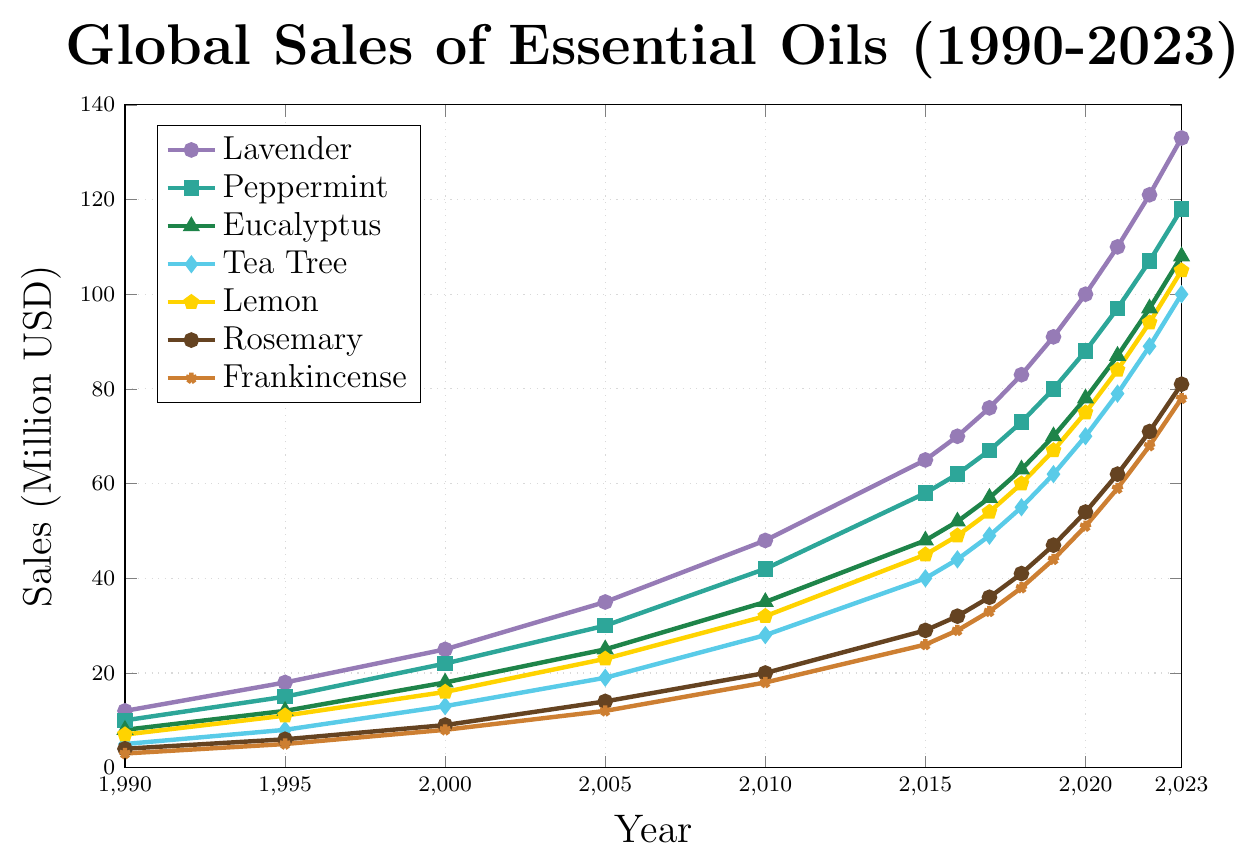What is the overall trend in the sales of Lavender essential oil from 1990 to 2023? Observe the line chart for Lavender's sales, indicated by the lavender-colored line with circular markers. The line shows a consistent upward trend from 1990 (12 million USD) to 2023 (133 million USD).
Answer: Increasing Which essential oil had the highest sales in 2023, and what was the sales figure? Compare the final points (year 2023) for all lines. The Lavender oil line reaches the highest point at 133 million USD.
Answer: Lavender, 133 million USD Between 1995 and 2000, which essential oil showed the greatest increase in sales? Calculate the difference in sales for each essential oil between 1995 and 2000 (Lavender: 7, Peppermint: 7, Eucalyptus: 6, Tea Tree: 5, Lemon: 5, Rosemary: 3, Frankincense: 3). The highest increase is seen in Lavender and Peppermint, with a 7 million USD increase each.
Answer: Lavender and Peppermint By how much did Tea Tree oil sales increase from 2010 to 2020? Find the sales in 2010 (28 million USD) and 2020 (70 million USD) for Tea Tree oil and then calculate the difference (70 - 28 = 42).
Answer: 42 million USD Which essential oil had the least sales growth from 1990 to 2023? Calculate the overall growth from 1990 to 2023 for each oil (Lavender: 121, Peppermint: 108, Eucalyptus: 100, Tea Tree: 95, Lemon: 98, Rosemary: 77, Frankincense: 75). The least growth is seen in Frankincense, with a growth of 75 million USD.
Answer: Frankincense What is the average sales of Eucalyptus essential oil from 1990 to 2023? Sum the sales values for Eucalyptus from 1990 to 2023 (gamma: 8+12+18+25+35+48+52+57+63+70+78+87+97+108 = 760) and divide by the number of years (14). The average sales are 760 / 14 = approximately 54.29 million USD.
Answer: Approximately 54.29 million USD Compare the sales difference between Lemon and Rosemary essential oils in 2023. Identify the sales figures in 2023 (Lemon: 105 million USD, Rosemary: 81 million USD) and calculate the difference (105 - 81 = 24).
Answer: 24 million USD Which essential oil showed the least variability in sales over the period from 1990 to 2023? Estimate the variations for each oil by visually inspecting the smoothness of the line. Eucalyptus appears to have a more consistent and less variable growth compared to other oils.
Answer: Eucalyptus In what year did the sales for Peppermint oil surpass 50 million USD? Locate the point where Peppermint oil sales crossed 50 million USD on the chart, which occurred in the year 2015.
Answer: 2015 